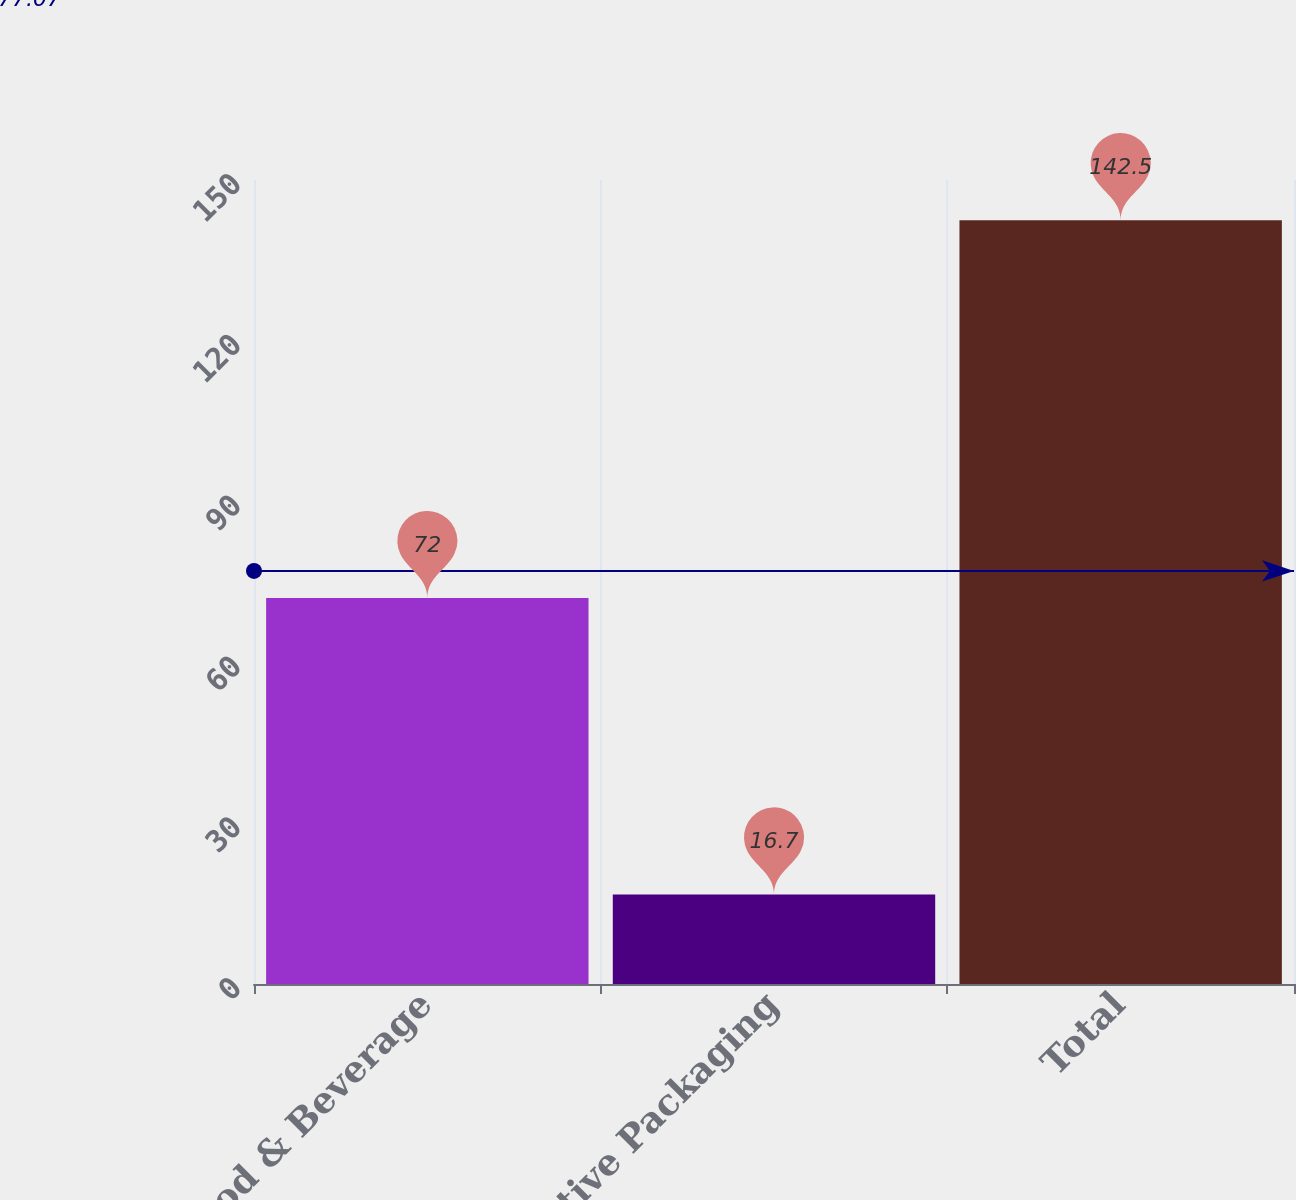Convert chart. <chart><loc_0><loc_0><loc_500><loc_500><bar_chart><fcel>Food & Beverage<fcel>Protective Packaging<fcel>Total<nl><fcel>72<fcel>16.7<fcel>142.5<nl></chart> 